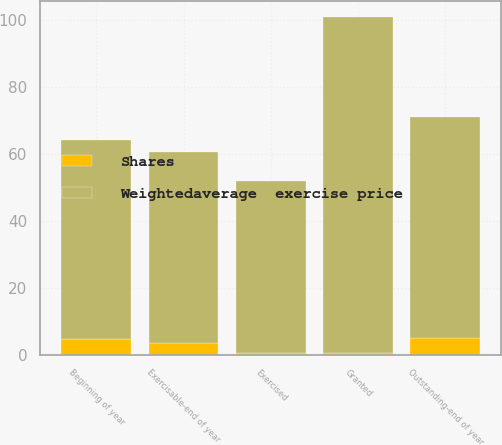<chart> <loc_0><loc_0><loc_500><loc_500><stacked_bar_chart><ecel><fcel>Beginning of year<fcel>Granted<fcel>Exercised<fcel>Outstanding-end of year<fcel>Exercisable-end of year<nl><fcel>Shares<fcel>4.8<fcel>0.7<fcel>0.6<fcel>4.9<fcel>3.4<nl><fcel>Weightedaverage  exercise price<fcel>59.2<fcel>99.92<fcel>51.26<fcel>66<fcel>56.97<nl></chart> 